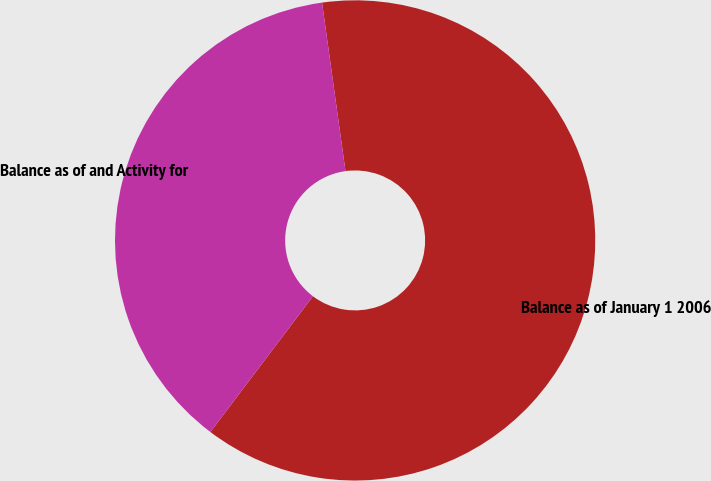<chart> <loc_0><loc_0><loc_500><loc_500><pie_chart><fcel>Balance as of January 1 2006<fcel>Balance as of and Activity for<nl><fcel>62.5%<fcel>37.5%<nl></chart> 